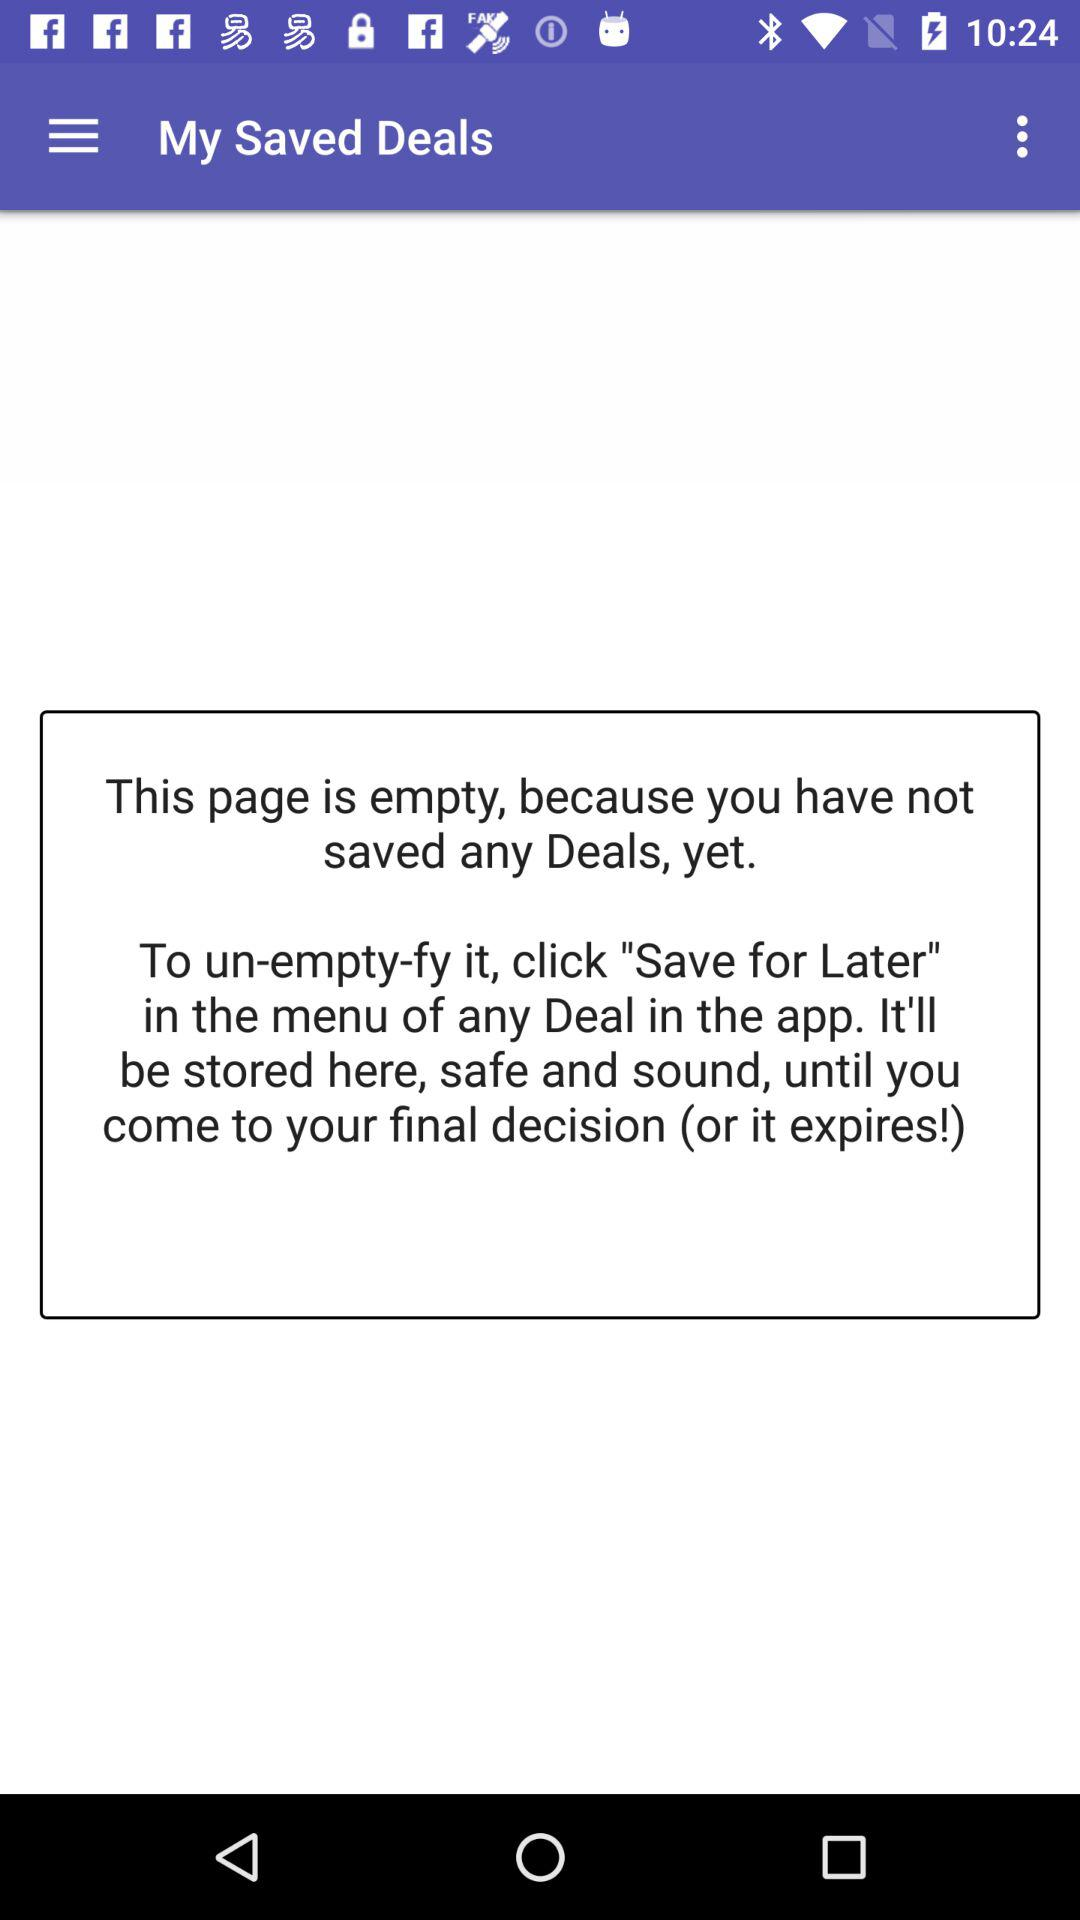How many deals have not been saved?
Answer the question using a single word or phrase. 0 